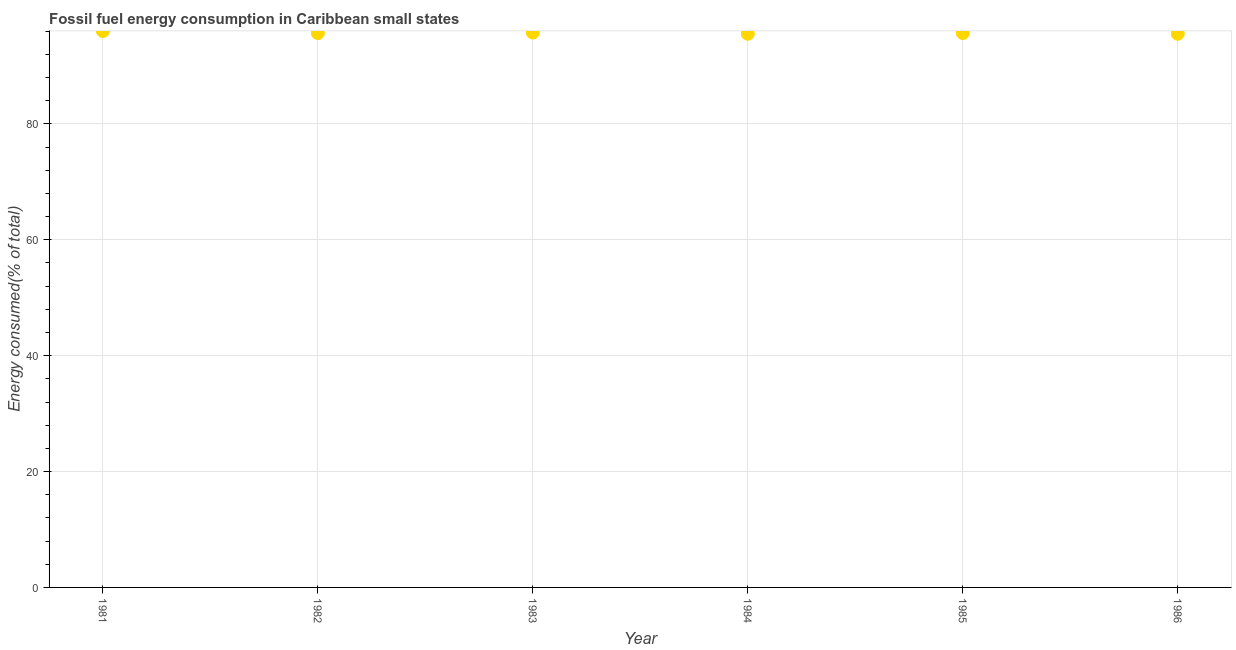What is the fossil fuel energy consumption in 1985?
Offer a very short reply. 95.68. Across all years, what is the maximum fossil fuel energy consumption?
Ensure brevity in your answer.  96.04. Across all years, what is the minimum fossil fuel energy consumption?
Offer a very short reply. 95.55. In which year was the fossil fuel energy consumption minimum?
Offer a very short reply. 1986. What is the sum of the fossil fuel energy consumption?
Your response must be concise. 574.24. What is the difference between the fossil fuel energy consumption in 1981 and 1985?
Provide a short and direct response. 0.36. What is the average fossil fuel energy consumption per year?
Your response must be concise. 95.71. What is the median fossil fuel energy consumption?
Keep it short and to the point. 95.67. In how many years, is the fossil fuel energy consumption greater than 48 %?
Give a very brief answer. 6. Do a majority of the years between 1985 and 1983 (inclusive) have fossil fuel energy consumption greater than 20 %?
Ensure brevity in your answer.  No. What is the ratio of the fossil fuel energy consumption in 1981 to that in 1982?
Offer a very short reply. 1. Is the fossil fuel energy consumption in 1983 less than that in 1984?
Ensure brevity in your answer.  No. Is the difference between the fossil fuel energy consumption in 1982 and 1986 greater than the difference between any two years?
Offer a very short reply. No. What is the difference between the highest and the second highest fossil fuel energy consumption?
Offer a very short reply. 0.28. Is the sum of the fossil fuel energy consumption in 1982 and 1983 greater than the maximum fossil fuel energy consumption across all years?
Your answer should be very brief. Yes. What is the difference between the highest and the lowest fossil fuel energy consumption?
Provide a succinct answer. 0.49. Does the fossil fuel energy consumption monotonically increase over the years?
Make the answer very short. No. Are the values on the major ticks of Y-axis written in scientific E-notation?
Offer a terse response. No. Does the graph contain grids?
Provide a succinct answer. Yes. What is the title of the graph?
Offer a terse response. Fossil fuel energy consumption in Caribbean small states. What is the label or title of the X-axis?
Your response must be concise. Year. What is the label or title of the Y-axis?
Ensure brevity in your answer.  Energy consumed(% of total). What is the Energy consumed(% of total) in 1981?
Provide a short and direct response. 96.04. What is the Energy consumed(% of total) in 1982?
Your answer should be very brief. 95.67. What is the Energy consumed(% of total) in 1983?
Your answer should be very brief. 95.76. What is the Energy consumed(% of total) in 1984?
Offer a terse response. 95.56. What is the Energy consumed(% of total) in 1985?
Provide a succinct answer. 95.68. What is the Energy consumed(% of total) in 1986?
Offer a very short reply. 95.55. What is the difference between the Energy consumed(% of total) in 1981 and 1982?
Your answer should be very brief. 0.37. What is the difference between the Energy consumed(% of total) in 1981 and 1983?
Provide a succinct answer. 0.28. What is the difference between the Energy consumed(% of total) in 1981 and 1984?
Offer a terse response. 0.48. What is the difference between the Energy consumed(% of total) in 1981 and 1985?
Your answer should be compact. 0.36. What is the difference between the Energy consumed(% of total) in 1981 and 1986?
Your response must be concise. 0.49. What is the difference between the Energy consumed(% of total) in 1982 and 1983?
Offer a terse response. -0.09. What is the difference between the Energy consumed(% of total) in 1982 and 1984?
Make the answer very short. 0.11. What is the difference between the Energy consumed(% of total) in 1982 and 1985?
Your response must be concise. -0.01. What is the difference between the Energy consumed(% of total) in 1982 and 1986?
Your response must be concise. 0.12. What is the difference between the Energy consumed(% of total) in 1983 and 1984?
Keep it short and to the point. 0.2. What is the difference between the Energy consumed(% of total) in 1983 and 1985?
Ensure brevity in your answer.  0.08. What is the difference between the Energy consumed(% of total) in 1983 and 1986?
Offer a terse response. 0.21. What is the difference between the Energy consumed(% of total) in 1984 and 1985?
Provide a succinct answer. -0.12. What is the difference between the Energy consumed(% of total) in 1984 and 1986?
Keep it short and to the point. 0.01. What is the difference between the Energy consumed(% of total) in 1985 and 1986?
Give a very brief answer. 0.13. What is the ratio of the Energy consumed(% of total) in 1981 to that in 1984?
Offer a very short reply. 1. What is the ratio of the Energy consumed(% of total) in 1981 to that in 1985?
Provide a short and direct response. 1. What is the ratio of the Energy consumed(% of total) in 1982 to that in 1983?
Give a very brief answer. 1. What is the ratio of the Energy consumed(% of total) in 1982 to that in 1984?
Your response must be concise. 1. What is the ratio of the Energy consumed(% of total) in 1982 to that in 1986?
Provide a short and direct response. 1. What is the ratio of the Energy consumed(% of total) in 1983 to that in 1985?
Your answer should be compact. 1. What is the ratio of the Energy consumed(% of total) in 1984 to that in 1985?
Ensure brevity in your answer.  1. 